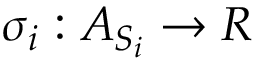Convert formula to latex. <formula><loc_0><loc_0><loc_500><loc_500>\sigma _ { i } \colon A _ { S _ { i } } \rightarrow R</formula> 